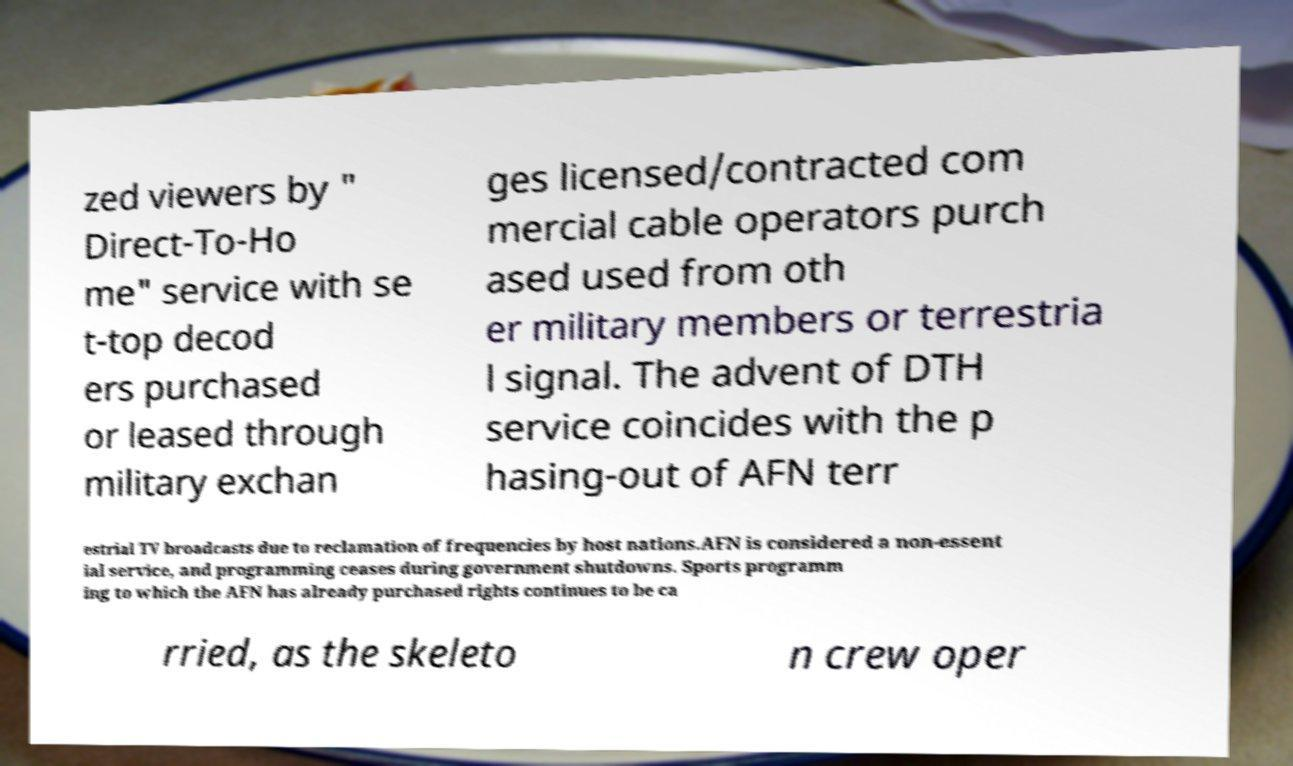I need the written content from this picture converted into text. Can you do that? zed viewers by " Direct-To-Ho me" service with se t-top decod ers purchased or leased through military exchan ges licensed/contracted com mercial cable operators purch ased used from oth er military members or terrestria l signal. The advent of DTH service coincides with the p hasing-out of AFN terr estrial TV broadcasts due to reclamation of frequencies by host nations.AFN is considered a non-essent ial service, and programming ceases during government shutdowns. Sports programm ing to which the AFN has already purchased rights continues to be ca rried, as the skeleto n crew oper 